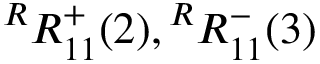<formula> <loc_0><loc_0><loc_500><loc_500>{ } ^ { R } R _ { 1 1 } ^ { + } ( 2 ) ^ { R } R _ { 1 1 } ^ { - } ( 3 )</formula> 